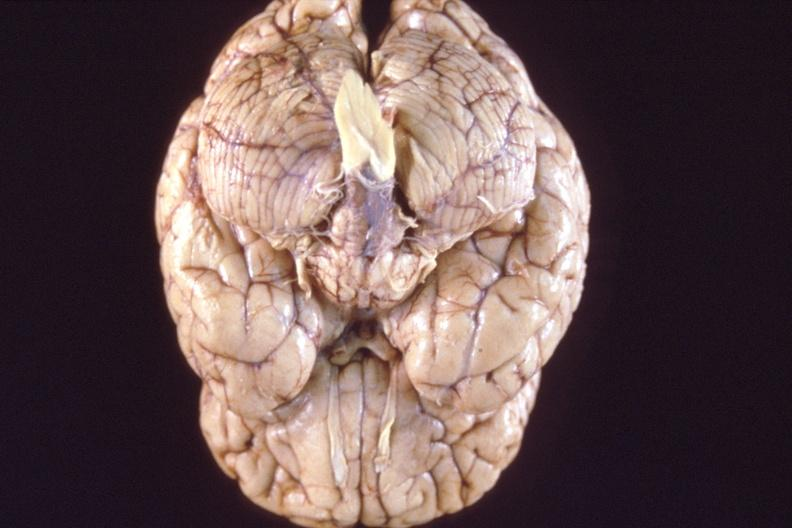what is present?
Answer the question using a single word or phrase. Nervous 